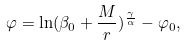Convert formula to latex. <formula><loc_0><loc_0><loc_500><loc_500>\varphi = \ln ( \beta _ { 0 } + \frac { M } { r } ) ^ { \frac { \gamma } { \alpha } } - \varphi _ { 0 } ,</formula> 